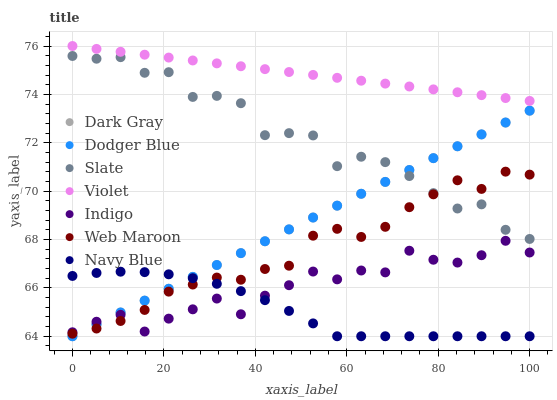Does Navy Blue have the minimum area under the curve?
Answer yes or no. Yes. Does Violet have the maximum area under the curve?
Answer yes or no. Yes. Does Slate have the minimum area under the curve?
Answer yes or no. No. Does Slate have the maximum area under the curve?
Answer yes or no. No. Is Dark Gray the smoothest?
Answer yes or no. Yes. Is Slate the roughest?
Answer yes or no. Yes. Is Navy Blue the smoothest?
Answer yes or no. No. Is Navy Blue the roughest?
Answer yes or no. No. Does Navy Blue have the lowest value?
Answer yes or no. Yes. Does Slate have the lowest value?
Answer yes or no. No. Does Violet have the highest value?
Answer yes or no. Yes. Does Slate have the highest value?
Answer yes or no. No. Is Web Maroon less than Violet?
Answer yes or no. Yes. Is Violet greater than Dark Gray?
Answer yes or no. Yes. Does Dodger Blue intersect Slate?
Answer yes or no. Yes. Is Dodger Blue less than Slate?
Answer yes or no. No. Is Dodger Blue greater than Slate?
Answer yes or no. No. Does Web Maroon intersect Violet?
Answer yes or no. No. 